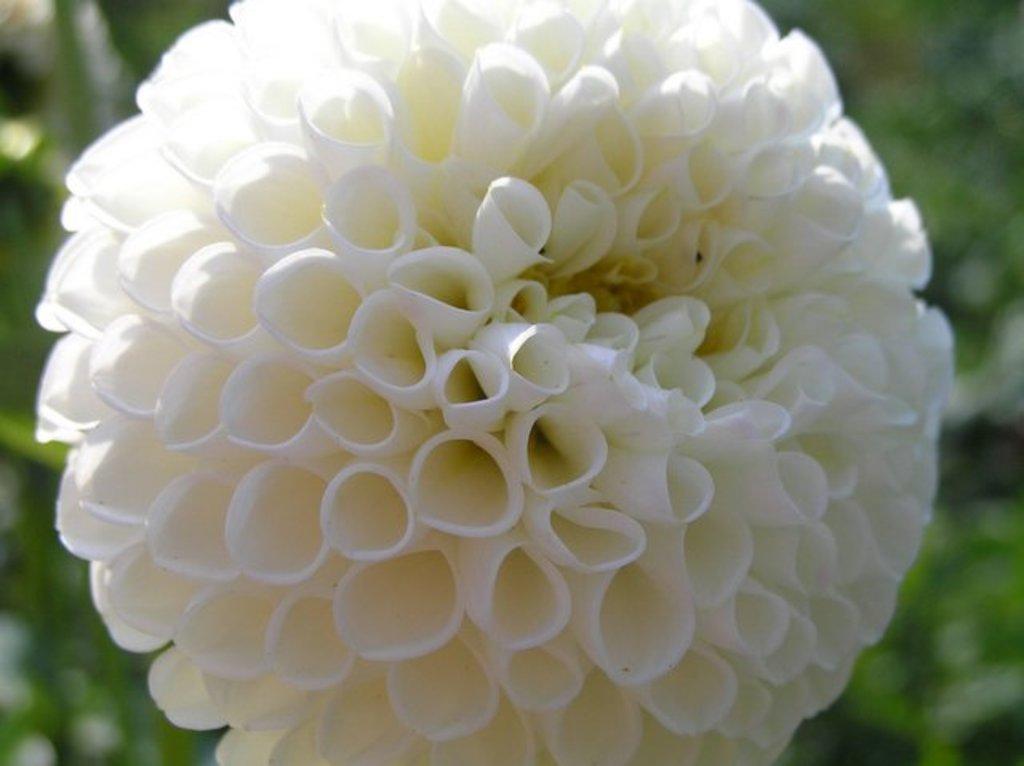Can you describe this image briefly? In this picture we can see a white flower. Behind the flower there is the blurred background. 